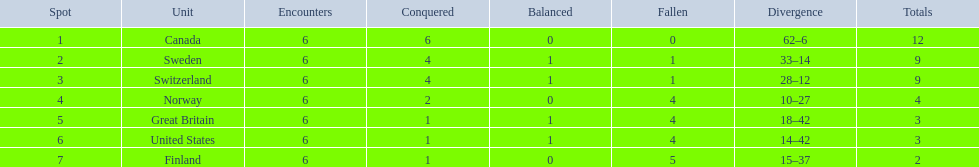Which are the two countries? Switzerland, Great Britain. What were the point totals for each of these countries? 9, 3. Of these point totals, which is better? 9. Which country earned this point total? Switzerland. 